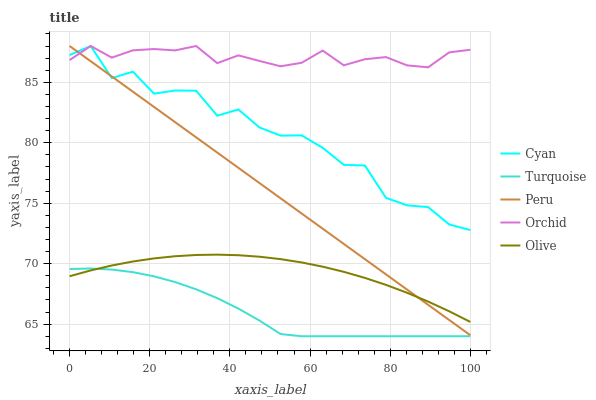Does Turquoise have the minimum area under the curve?
Answer yes or no. Yes. Does Orchid have the maximum area under the curve?
Answer yes or no. Yes. Does Cyan have the minimum area under the curve?
Answer yes or no. No. Does Cyan have the maximum area under the curve?
Answer yes or no. No. Is Peru the smoothest?
Answer yes or no. Yes. Is Cyan the roughest?
Answer yes or no. Yes. Is Turquoise the smoothest?
Answer yes or no. No. Is Turquoise the roughest?
Answer yes or no. No. Does Turquoise have the lowest value?
Answer yes or no. Yes. Does Cyan have the lowest value?
Answer yes or no. No. Does Orchid have the highest value?
Answer yes or no. Yes. Does Turquoise have the highest value?
Answer yes or no. No. Is Olive less than Cyan?
Answer yes or no. Yes. Is Orchid greater than Turquoise?
Answer yes or no. Yes. Does Orchid intersect Cyan?
Answer yes or no. Yes. Is Orchid less than Cyan?
Answer yes or no. No. Is Orchid greater than Cyan?
Answer yes or no. No. Does Olive intersect Cyan?
Answer yes or no. No. 